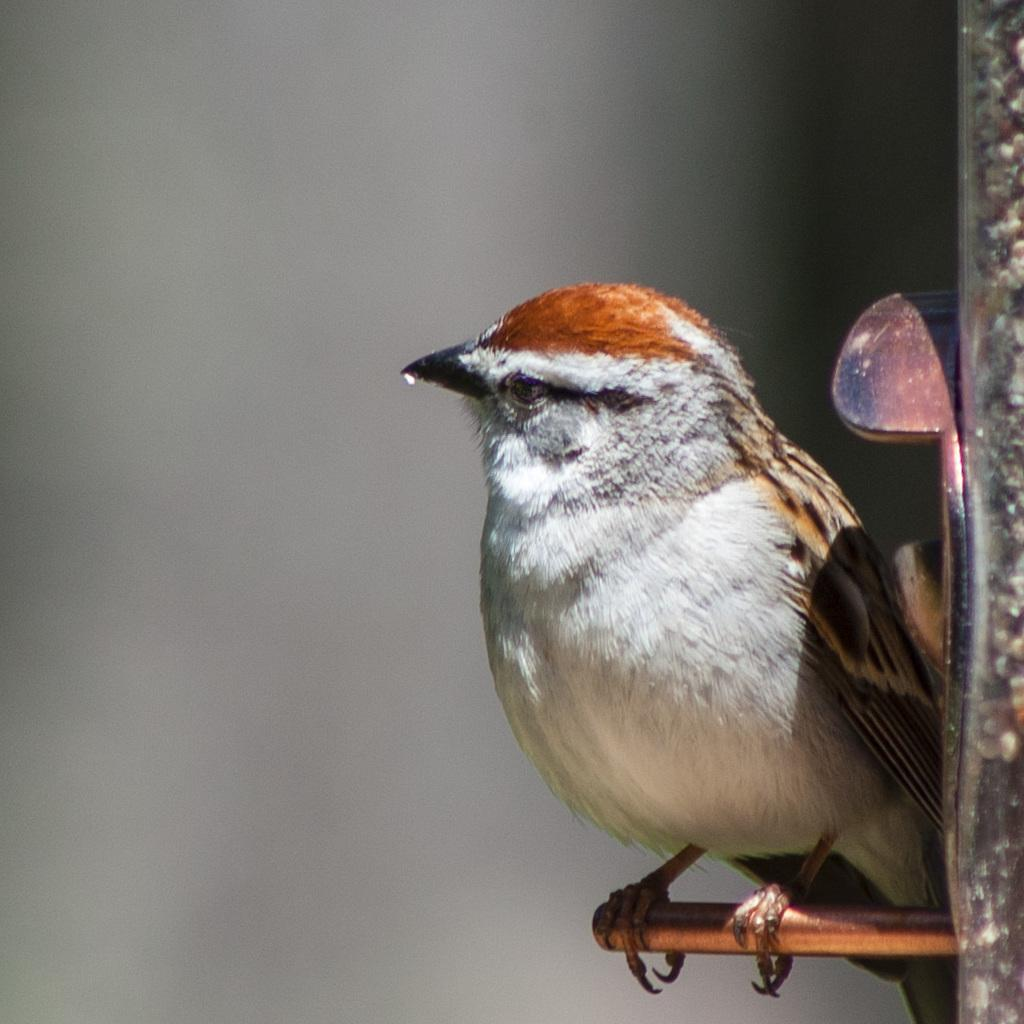What type of animal is in the image? There is a bird in the image. What is the bird doing in the image? The bird is standing on an object. Can you describe the background of the image? The background of the image is blurred. What time does the clock show in the image? There is no clock present in the image. What type of error can be seen in the image? There is no error present in the image. 